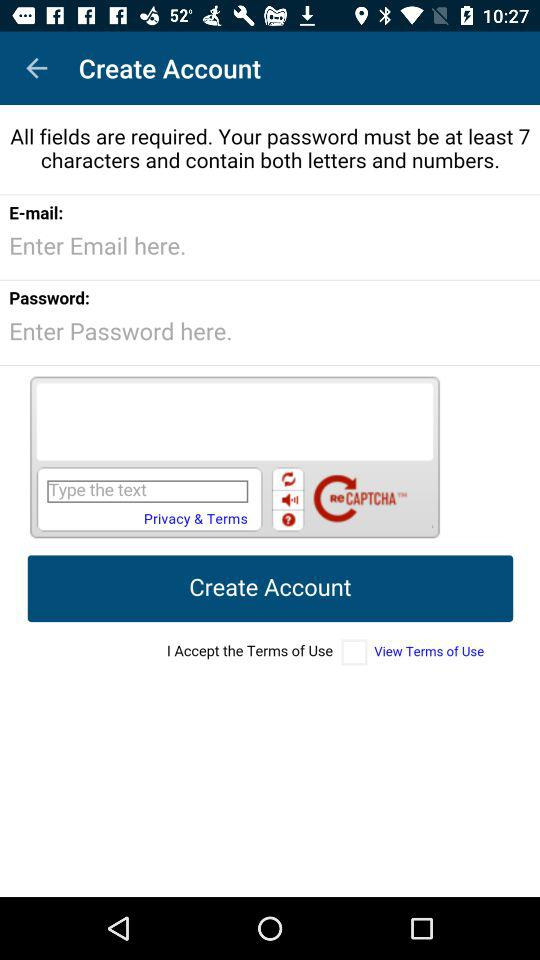What is the status of "I Accept the Terms of Use"? The status is "off". 